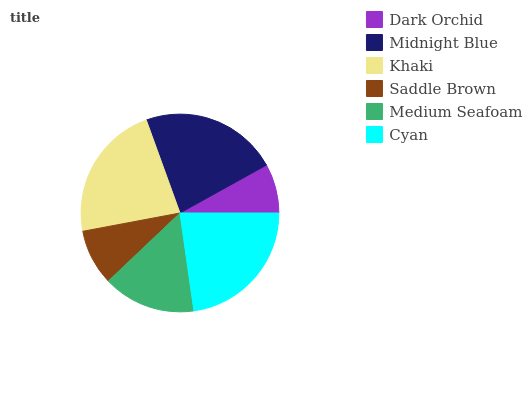Is Dark Orchid the minimum?
Answer yes or no. Yes. Is Cyan the maximum?
Answer yes or no. Yes. Is Midnight Blue the minimum?
Answer yes or no. No. Is Midnight Blue the maximum?
Answer yes or no. No. Is Midnight Blue greater than Dark Orchid?
Answer yes or no. Yes. Is Dark Orchid less than Midnight Blue?
Answer yes or no. Yes. Is Dark Orchid greater than Midnight Blue?
Answer yes or no. No. Is Midnight Blue less than Dark Orchid?
Answer yes or no. No. Is Khaki the high median?
Answer yes or no. Yes. Is Medium Seafoam the low median?
Answer yes or no. Yes. Is Medium Seafoam the high median?
Answer yes or no. No. Is Cyan the low median?
Answer yes or no. No. 